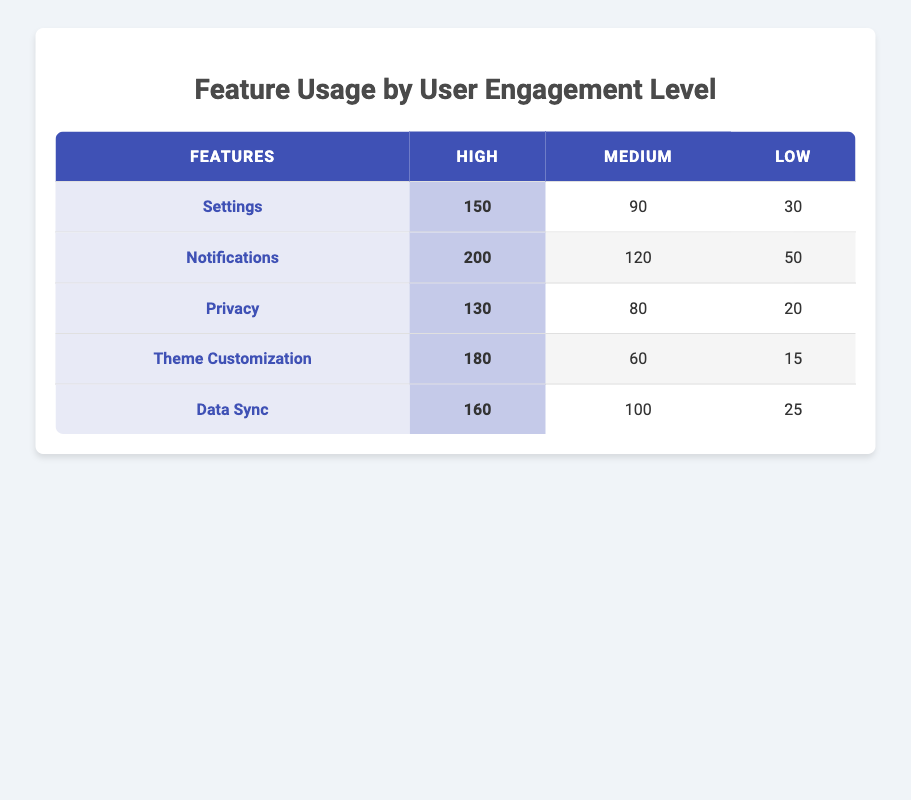What is the frequency of feature usage for Notifications at a High engagement level? The table lists the frequency of feature usage for Notifications in the corresponding engagement levels. Referring to the High column for Notifications, the value is 200.
Answer: 200 Which feature has the lowest usage frequency at a Medium engagement level? Looking at the Medium column, the values are 90 for Settings, 120 for Notifications, 80 for Privacy, 60 for Theme Customization, and 100 for Data Sync. The lowest value here is 60, associated with Theme Customization.
Answer: Theme Customization What is the total frequency of feature usage at a Low engagement level? To find the total frequency for the Low engagement level, we need to sum the values: 30 (Settings) + 50 (Notifications) + 20 (Privacy) + 15 (Theme Customization) + 25 (Data Sync) = 140.
Answer: 140 Is the frequency of feature usage for Privacy at a High engagement level greater than that for Theme Customization at a Medium engagement level? Looking at the table, the value for Privacy at a High engagement level is 130, while the value for Theme Customization at a Medium engagement level is 60. Since 130 is greater than 60, the statement is true.
Answer: Yes What is the difference in usage frequency between the highest and lowest usage features at a High engagement level? The highest usage at a High engagement level is 200 for Notifications, and the lowest is 130 for Privacy. The difference is calculated as 200 - 130 = 70.
Answer: 70 